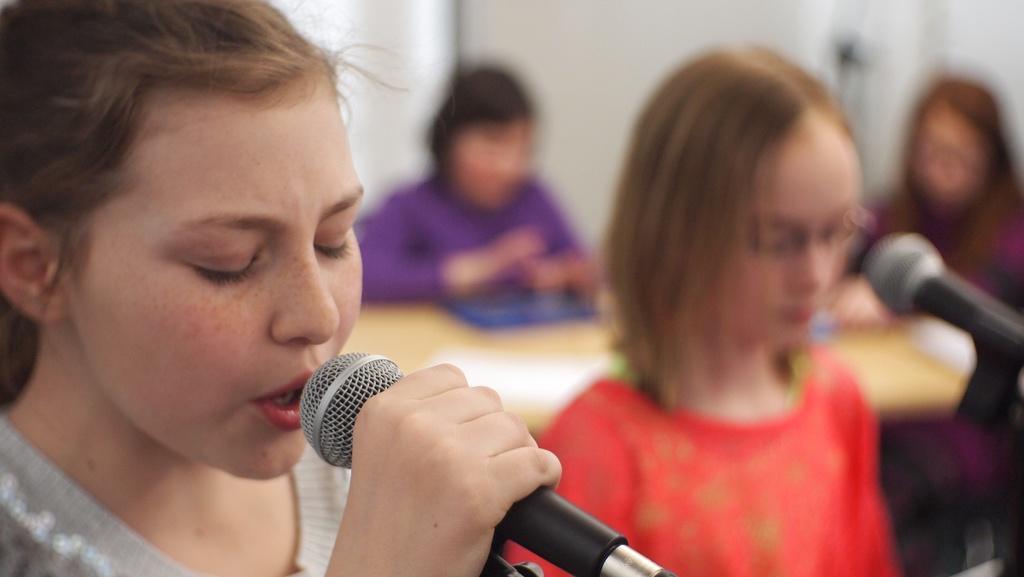Can you describe this image briefly? In this image there are four girls. To the left a girl is wearing a gray color shirt and singing in the mic. To the right the girl is wearing red color dress. In the background the two girls are sitting in front of the table. 